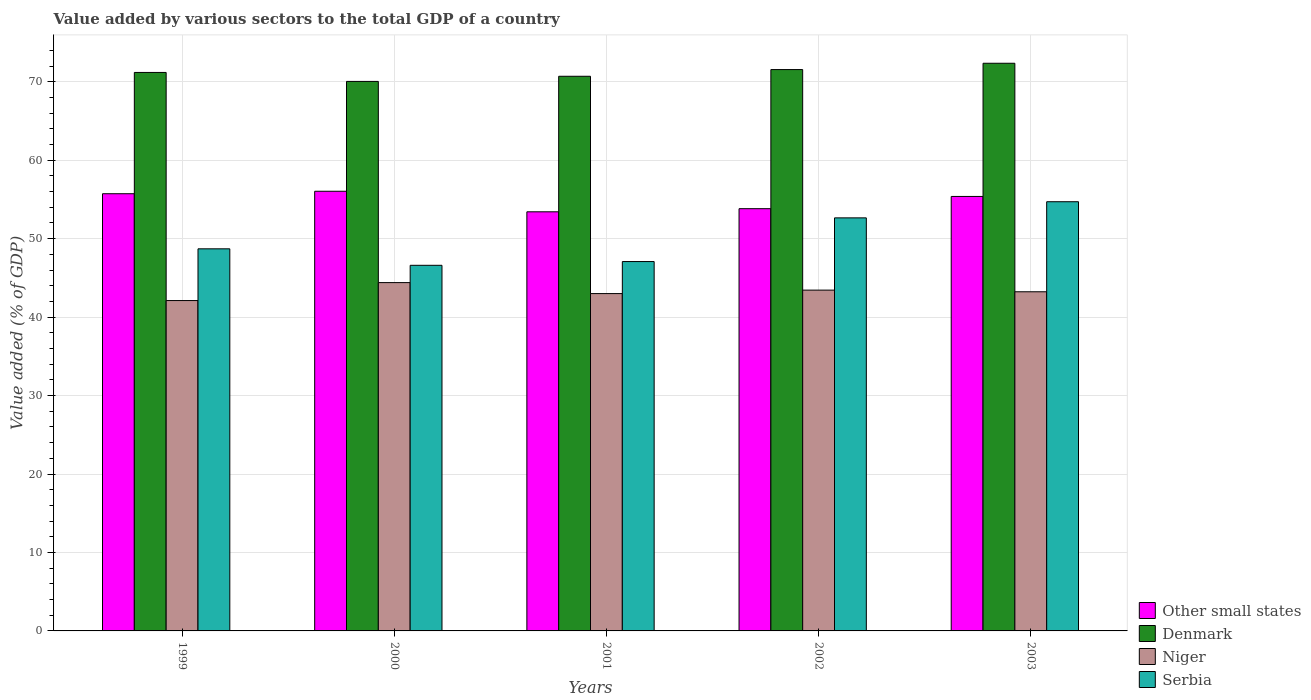How many different coloured bars are there?
Your answer should be very brief. 4. Are the number of bars per tick equal to the number of legend labels?
Ensure brevity in your answer.  Yes. What is the value added by various sectors to the total GDP in Niger in 2000?
Offer a very short reply. 44.4. Across all years, what is the maximum value added by various sectors to the total GDP in Niger?
Your answer should be compact. 44.4. Across all years, what is the minimum value added by various sectors to the total GDP in Other small states?
Keep it short and to the point. 53.43. In which year was the value added by various sectors to the total GDP in Other small states maximum?
Provide a short and direct response. 2000. What is the total value added by various sectors to the total GDP in Other small states in the graph?
Your answer should be compact. 274.41. What is the difference between the value added by various sectors to the total GDP in Denmark in 1999 and that in 2003?
Your answer should be compact. -1.17. What is the difference between the value added by various sectors to the total GDP in Other small states in 2000 and the value added by various sectors to the total GDP in Denmark in 2003?
Your answer should be compact. -16.32. What is the average value added by various sectors to the total GDP in Other small states per year?
Provide a succinct answer. 54.88. In the year 2002, what is the difference between the value added by various sectors to the total GDP in Serbia and value added by various sectors to the total GDP in Denmark?
Offer a very short reply. -18.9. In how many years, is the value added by various sectors to the total GDP in Niger greater than 38 %?
Provide a short and direct response. 5. What is the ratio of the value added by various sectors to the total GDP in Serbia in 2002 to that in 2003?
Your answer should be very brief. 0.96. What is the difference between the highest and the second highest value added by various sectors to the total GDP in Denmark?
Ensure brevity in your answer.  0.8. What is the difference between the highest and the lowest value added by various sectors to the total GDP in Serbia?
Make the answer very short. 8.1. In how many years, is the value added by various sectors to the total GDP in Other small states greater than the average value added by various sectors to the total GDP in Other small states taken over all years?
Give a very brief answer. 3. Is it the case that in every year, the sum of the value added by various sectors to the total GDP in Niger and value added by various sectors to the total GDP in Serbia is greater than the sum of value added by various sectors to the total GDP in Other small states and value added by various sectors to the total GDP in Denmark?
Offer a terse response. No. What does the 3rd bar from the left in 2002 represents?
Keep it short and to the point. Niger. What does the 2nd bar from the right in 2003 represents?
Give a very brief answer. Niger. Is it the case that in every year, the sum of the value added by various sectors to the total GDP in Niger and value added by various sectors to the total GDP in Other small states is greater than the value added by various sectors to the total GDP in Denmark?
Make the answer very short. Yes. What is the difference between two consecutive major ticks on the Y-axis?
Provide a short and direct response. 10. Are the values on the major ticks of Y-axis written in scientific E-notation?
Your answer should be compact. No. Does the graph contain any zero values?
Keep it short and to the point. No. Does the graph contain grids?
Your answer should be compact. Yes. How many legend labels are there?
Offer a terse response. 4. What is the title of the graph?
Provide a succinct answer. Value added by various sectors to the total GDP of a country. What is the label or title of the Y-axis?
Provide a succinct answer. Value added (% of GDP). What is the Value added (% of GDP) in Other small states in 1999?
Give a very brief answer. 55.73. What is the Value added (% of GDP) in Denmark in 1999?
Offer a terse response. 71.19. What is the Value added (% of GDP) in Niger in 1999?
Your response must be concise. 42.11. What is the Value added (% of GDP) in Serbia in 1999?
Give a very brief answer. 48.71. What is the Value added (% of GDP) of Other small states in 2000?
Provide a short and direct response. 56.04. What is the Value added (% of GDP) in Denmark in 2000?
Provide a short and direct response. 70.05. What is the Value added (% of GDP) in Niger in 2000?
Offer a very short reply. 44.4. What is the Value added (% of GDP) of Serbia in 2000?
Ensure brevity in your answer.  46.61. What is the Value added (% of GDP) in Other small states in 2001?
Your answer should be compact. 53.43. What is the Value added (% of GDP) in Denmark in 2001?
Provide a succinct answer. 70.7. What is the Value added (% of GDP) in Niger in 2001?
Your response must be concise. 43. What is the Value added (% of GDP) in Serbia in 2001?
Offer a terse response. 47.08. What is the Value added (% of GDP) in Other small states in 2002?
Offer a terse response. 53.82. What is the Value added (% of GDP) in Denmark in 2002?
Offer a very short reply. 71.56. What is the Value added (% of GDP) of Niger in 2002?
Provide a short and direct response. 43.44. What is the Value added (% of GDP) of Serbia in 2002?
Make the answer very short. 52.65. What is the Value added (% of GDP) of Other small states in 2003?
Offer a terse response. 55.38. What is the Value added (% of GDP) of Denmark in 2003?
Offer a very short reply. 72.36. What is the Value added (% of GDP) in Niger in 2003?
Provide a succinct answer. 43.23. What is the Value added (% of GDP) of Serbia in 2003?
Your answer should be compact. 54.71. Across all years, what is the maximum Value added (% of GDP) in Other small states?
Your response must be concise. 56.04. Across all years, what is the maximum Value added (% of GDP) in Denmark?
Ensure brevity in your answer.  72.36. Across all years, what is the maximum Value added (% of GDP) in Niger?
Offer a terse response. 44.4. Across all years, what is the maximum Value added (% of GDP) of Serbia?
Provide a short and direct response. 54.71. Across all years, what is the minimum Value added (% of GDP) of Other small states?
Make the answer very short. 53.43. Across all years, what is the minimum Value added (% of GDP) of Denmark?
Make the answer very short. 70.05. Across all years, what is the minimum Value added (% of GDP) of Niger?
Your response must be concise. 42.11. Across all years, what is the minimum Value added (% of GDP) of Serbia?
Provide a short and direct response. 46.61. What is the total Value added (% of GDP) of Other small states in the graph?
Give a very brief answer. 274.41. What is the total Value added (% of GDP) in Denmark in the graph?
Provide a short and direct response. 355.86. What is the total Value added (% of GDP) of Niger in the graph?
Your answer should be very brief. 216.19. What is the total Value added (% of GDP) of Serbia in the graph?
Offer a very short reply. 249.76. What is the difference between the Value added (% of GDP) in Other small states in 1999 and that in 2000?
Make the answer very short. -0.31. What is the difference between the Value added (% of GDP) of Denmark in 1999 and that in 2000?
Offer a terse response. 1.14. What is the difference between the Value added (% of GDP) of Niger in 1999 and that in 2000?
Your response must be concise. -2.29. What is the difference between the Value added (% of GDP) in Serbia in 1999 and that in 2000?
Make the answer very short. 2.1. What is the difference between the Value added (% of GDP) of Other small states in 1999 and that in 2001?
Provide a short and direct response. 2.3. What is the difference between the Value added (% of GDP) in Denmark in 1999 and that in 2001?
Provide a succinct answer. 0.49. What is the difference between the Value added (% of GDP) in Niger in 1999 and that in 2001?
Make the answer very short. -0.89. What is the difference between the Value added (% of GDP) of Serbia in 1999 and that in 2001?
Give a very brief answer. 1.62. What is the difference between the Value added (% of GDP) of Other small states in 1999 and that in 2002?
Ensure brevity in your answer.  1.91. What is the difference between the Value added (% of GDP) of Denmark in 1999 and that in 2002?
Your response must be concise. -0.37. What is the difference between the Value added (% of GDP) of Niger in 1999 and that in 2002?
Offer a very short reply. -1.33. What is the difference between the Value added (% of GDP) of Serbia in 1999 and that in 2002?
Provide a short and direct response. -3.95. What is the difference between the Value added (% of GDP) in Other small states in 1999 and that in 2003?
Your answer should be compact. 0.35. What is the difference between the Value added (% of GDP) in Denmark in 1999 and that in 2003?
Keep it short and to the point. -1.17. What is the difference between the Value added (% of GDP) in Niger in 1999 and that in 2003?
Offer a very short reply. -1.12. What is the difference between the Value added (% of GDP) of Serbia in 1999 and that in 2003?
Make the answer very short. -6. What is the difference between the Value added (% of GDP) of Other small states in 2000 and that in 2001?
Make the answer very short. 2.62. What is the difference between the Value added (% of GDP) in Denmark in 2000 and that in 2001?
Make the answer very short. -0.66. What is the difference between the Value added (% of GDP) of Niger in 2000 and that in 2001?
Provide a short and direct response. 1.4. What is the difference between the Value added (% of GDP) in Serbia in 2000 and that in 2001?
Your response must be concise. -0.48. What is the difference between the Value added (% of GDP) in Other small states in 2000 and that in 2002?
Offer a very short reply. 2.22. What is the difference between the Value added (% of GDP) of Denmark in 2000 and that in 2002?
Your response must be concise. -1.51. What is the difference between the Value added (% of GDP) in Niger in 2000 and that in 2002?
Your answer should be very brief. 0.96. What is the difference between the Value added (% of GDP) of Serbia in 2000 and that in 2002?
Give a very brief answer. -6.05. What is the difference between the Value added (% of GDP) of Other small states in 2000 and that in 2003?
Your answer should be very brief. 0.66. What is the difference between the Value added (% of GDP) of Denmark in 2000 and that in 2003?
Keep it short and to the point. -2.31. What is the difference between the Value added (% of GDP) in Niger in 2000 and that in 2003?
Give a very brief answer. 1.17. What is the difference between the Value added (% of GDP) in Serbia in 2000 and that in 2003?
Your answer should be compact. -8.1. What is the difference between the Value added (% of GDP) of Other small states in 2001 and that in 2002?
Give a very brief answer. -0.4. What is the difference between the Value added (% of GDP) of Denmark in 2001 and that in 2002?
Your answer should be very brief. -0.85. What is the difference between the Value added (% of GDP) in Niger in 2001 and that in 2002?
Offer a very short reply. -0.44. What is the difference between the Value added (% of GDP) of Serbia in 2001 and that in 2002?
Keep it short and to the point. -5.57. What is the difference between the Value added (% of GDP) of Other small states in 2001 and that in 2003?
Keep it short and to the point. -1.96. What is the difference between the Value added (% of GDP) in Denmark in 2001 and that in 2003?
Ensure brevity in your answer.  -1.66. What is the difference between the Value added (% of GDP) in Niger in 2001 and that in 2003?
Offer a terse response. -0.23. What is the difference between the Value added (% of GDP) in Serbia in 2001 and that in 2003?
Keep it short and to the point. -7.63. What is the difference between the Value added (% of GDP) of Other small states in 2002 and that in 2003?
Make the answer very short. -1.56. What is the difference between the Value added (% of GDP) in Denmark in 2002 and that in 2003?
Make the answer very short. -0.8. What is the difference between the Value added (% of GDP) in Niger in 2002 and that in 2003?
Offer a very short reply. 0.21. What is the difference between the Value added (% of GDP) of Serbia in 2002 and that in 2003?
Offer a terse response. -2.06. What is the difference between the Value added (% of GDP) of Other small states in 1999 and the Value added (% of GDP) of Denmark in 2000?
Provide a succinct answer. -14.32. What is the difference between the Value added (% of GDP) of Other small states in 1999 and the Value added (% of GDP) of Niger in 2000?
Provide a succinct answer. 11.33. What is the difference between the Value added (% of GDP) in Other small states in 1999 and the Value added (% of GDP) in Serbia in 2000?
Your response must be concise. 9.12. What is the difference between the Value added (% of GDP) of Denmark in 1999 and the Value added (% of GDP) of Niger in 2000?
Your response must be concise. 26.79. What is the difference between the Value added (% of GDP) of Denmark in 1999 and the Value added (% of GDP) of Serbia in 2000?
Your answer should be very brief. 24.58. What is the difference between the Value added (% of GDP) in Niger in 1999 and the Value added (% of GDP) in Serbia in 2000?
Offer a terse response. -4.49. What is the difference between the Value added (% of GDP) in Other small states in 1999 and the Value added (% of GDP) in Denmark in 2001?
Your answer should be compact. -14.97. What is the difference between the Value added (% of GDP) in Other small states in 1999 and the Value added (% of GDP) in Niger in 2001?
Provide a short and direct response. 12.73. What is the difference between the Value added (% of GDP) in Other small states in 1999 and the Value added (% of GDP) in Serbia in 2001?
Make the answer very short. 8.65. What is the difference between the Value added (% of GDP) in Denmark in 1999 and the Value added (% of GDP) in Niger in 2001?
Your answer should be very brief. 28.19. What is the difference between the Value added (% of GDP) in Denmark in 1999 and the Value added (% of GDP) in Serbia in 2001?
Your answer should be compact. 24.11. What is the difference between the Value added (% of GDP) in Niger in 1999 and the Value added (% of GDP) in Serbia in 2001?
Provide a short and direct response. -4.97. What is the difference between the Value added (% of GDP) in Other small states in 1999 and the Value added (% of GDP) in Denmark in 2002?
Your response must be concise. -15.83. What is the difference between the Value added (% of GDP) of Other small states in 1999 and the Value added (% of GDP) of Niger in 2002?
Keep it short and to the point. 12.29. What is the difference between the Value added (% of GDP) of Other small states in 1999 and the Value added (% of GDP) of Serbia in 2002?
Make the answer very short. 3.08. What is the difference between the Value added (% of GDP) in Denmark in 1999 and the Value added (% of GDP) in Niger in 2002?
Your answer should be very brief. 27.75. What is the difference between the Value added (% of GDP) in Denmark in 1999 and the Value added (% of GDP) in Serbia in 2002?
Offer a very short reply. 18.54. What is the difference between the Value added (% of GDP) of Niger in 1999 and the Value added (% of GDP) of Serbia in 2002?
Make the answer very short. -10.54. What is the difference between the Value added (% of GDP) in Other small states in 1999 and the Value added (% of GDP) in Denmark in 2003?
Offer a terse response. -16.63. What is the difference between the Value added (% of GDP) of Other small states in 1999 and the Value added (% of GDP) of Niger in 2003?
Your answer should be very brief. 12.5. What is the difference between the Value added (% of GDP) in Other small states in 1999 and the Value added (% of GDP) in Serbia in 2003?
Your answer should be very brief. 1.02. What is the difference between the Value added (% of GDP) in Denmark in 1999 and the Value added (% of GDP) in Niger in 2003?
Your answer should be very brief. 27.96. What is the difference between the Value added (% of GDP) of Denmark in 1999 and the Value added (% of GDP) of Serbia in 2003?
Provide a succinct answer. 16.48. What is the difference between the Value added (% of GDP) in Niger in 1999 and the Value added (% of GDP) in Serbia in 2003?
Offer a terse response. -12.6. What is the difference between the Value added (% of GDP) of Other small states in 2000 and the Value added (% of GDP) of Denmark in 2001?
Your answer should be very brief. -14.66. What is the difference between the Value added (% of GDP) in Other small states in 2000 and the Value added (% of GDP) in Niger in 2001?
Your answer should be compact. 13.04. What is the difference between the Value added (% of GDP) in Other small states in 2000 and the Value added (% of GDP) in Serbia in 2001?
Provide a succinct answer. 8.96. What is the difference between the Value added (% of GDP) in Denmark in 2000 and the Value added (% of GDP) in Niger in 2001?
Keep it short and to the point. 27.05. What is the difference between the Value added (% of GDP) in Denmark in 2000 and the Value added (% of GDP) in Serbia in 2001?
Your response must be concise. 22.96. What is the difference between the Value added (% of GDP) in Niger in 2000 and the Value added (% of GDP) in Serbia in 2001?
Offer a very short reply. -2.68. What is the difference between the Value added (% of GDP) of Other small states in 2000 and the Value added (% of GDP) of Denmark in 2002?
Keep it short and to the point. -15.51. What is the difference between the Value added (% of GDP) in Other small states in 2000 and the Value added (% of GDP) in Niger in 2002?
Your answer should be very brief. 12.6. What is the difference between the Value added (% of GDP) in Other small states in 2000 and the Value added (% of GDP) in Serbia in 2002?
Your answer should be compact. 3.39. What is the difference between the Value added (% of GDP) of Denmark in 2000 and the Value added (% of GDP) of Niger in 2002?
Make the answer very short. 26.6. What is the difference between the Value added (% of GDP) of Denmark in 2000 and the Value added (% of GDP) of Serbia in 2002?
Your response must be concise. 17.39. What is the difference between the Value added (% of GDP) in Niger in 2000 and the Value added (% of GDP) in Serbia in 2002?
Provide a short and direct response. -8.25. What is the difference between the Value added (% of GDP) in Other small states in 2000 and the Value added (% of GDP) in Denmark in 2003?
Keep it short and to the point. -16.32. What is the difference between the Value added (% of GDP) in Other small states in 2000 and the Value added (% of GDP) in Niger in 2003?
Provide a short and direct response. 12.81. What is the difference between the Value added (% of GDP) in Other small states in 2000 and the Value added (% of GDP) in Serbia in 2003?
Offer a terse response. 1.33. What is the difference between the Value added (% of GDP) in Denmark in 2000 and the Value added (% of GDP) in Niger in 2003?
Offer a terse response. 26.82. What is the difference between the Value added (% of GDP) of Denmark in 2000 and the Value added (% of GDP) of Serbia in 2003?
Keep it short and to the point. 15.34. What is the difference between the Value added (% of GDP) of Niger in 2000 and the Value added (% of GDP) of Serbia in 2003?
Offer a very short reply. -10.31. What is the difference between the Value added (% of GDP) of Other small states in 2001 and the Value added (% of GDP) of Denmark in 2002?
Your answer should be compact. -18.13. What is the difference between the Value added (% of GDP) of Other small states in 2001 and the Value added (% of GDP) of Niger in 2002?
Keep it short and to the point. 9.98. What is the difference between the Value added (% of GDP) in Other small states in 2001 and the Value added (% of GDP) in Serbia in 2002?
Provide a succinct answer. 0.77. What is the difference between the Value added (% of GDP) in Denmark in 2001 and the Value added (% of GDP) in Niger in 2002?
Give a very brief answer. 27.26. What is the difference between the Value added (% of GDP) in Denmark in 2001 and the Value added (% of GDP) in Serbia in 2002?
Make the answer very short. 18.05. What is the difference between the Value added (% of GDP) in Niger in 2001 and the Value added (% of GDP) in Serbia in 2002?
Provide a succinct answer. -9.65. What is the difference between the Value added (% of GDP) in Other small states in 2001 and the Value added (% of GDP) in Denmark in 2003?
Your answer should be very brief. -18.93. What is the difference between the Value added (% of GDP) in Other small states in 2001 and the Value added (% of GDP) in Niger in 2003?
Offer a terse response. 10.19. What is the difference between the Value added (% of GDP) in Other small states in 2001 and the Value added (% of GDP) in Serbia in 2003?
Your answer should be very brief. -1.28. What is the difference between the Value added (% of GDP) in Denmark in 2001 and the Value added (% of GDP) in Niger in 2003?
Your response must be concise. 27.47. What is the difference between the Value added (% of GDP) in Denmark in 2001 and the Value added (% of GDP) in Serbia in 2003?
Make the answer very short. 15.99. What is the difference between the Value added (% of GDP) in Niger in 2001 and the Value added (% of GDP) in Serbia in 2003?
Your answer should be compact. -11.71. What is the difference between the Value added (% of GDP) of Other small states in 2002 and the Value added (% of GDP) of Denmark in 2003?
Your response must be concise. -18.54. What is the difference between the Value added (% of GDP) of Other small states in 2002 and the Value added (% of GDP) of Niger in 2003?
Your answer should be very brief. 10.59. What is the difference between the Value added (% of GDP) in Other small states in 2002 and the Value added (% of GDP) in Serbia in 2003?
Your response must be concise. -0.89. What is the difference between the Value added (% of GDP) of Denmark in 2002 and the Value added (% of GDP) of Niger in 2003?
Offer a very short reply. 28.32. What is the difference between the Value added (% of GDP) of Denmark in 2002 and the Value added (% of GDP) of Serbia in 2003?
Offer a terse response. 16.85. What is the difference between the Value added (% of GDP) in Niger in 2002 and the Value added (% of GDP) in Serbia in 2003?
Offer a very short reply. -11.27. What is the average Value added (% of GDP) of Other small states per year?
Offer a very short reply. 54.88. What is the average Value added (% of GDP) of Denmark per year?
Your answer should be very brief. 71.17. What is the average Value added (% of GDP) in Niger per year?
Offer a terse response. 43.24. What is the average Value added (% of GDP) of Serbia per year?
Offer a very short reply. 49.95. In the year 1999, what is the difference between the Value added (% of GDP) in Other small states and Value added (% of GDP) in Denmark?
Provide a short and direct response. -15.46. In the year 1999, what is the difference between the Value added (% of GDP) of Other small states and Value added (% of GDP) of Niger?
Provide a succinct answer. 13.62. In the year 1999, what is the difference between the Value added (% of GDP) of Other small states and Value added (% of GDP) of Serbia?
Your response must be concise. 7.02. In the year 1999, what is the difference between the Value added (% of GDP) of Denmark and Value added (% of GDP) of Niger?
Provide a short and direct response. 29.08. In the year 1999, what is the difference between the Value added (% of GDP) of Denmark and Value added (% of GDP) of Serbia?
Your answer should be very brief. 22.48. In the year 1999, what is the difference between the Value added (% of GDP) in Niger and Value added (% of GDP) in Serbia?
Give a very brief answer. -6.59. In the year 2000, what is the difference between the Value added (% of GDP) of Other small states and Value added (% of GDP) of Denmark?
Provide a short and direct response. -14. In the year 2000, what is the difference between the Value added (% of GDP) in Other small states and Value added (% of GDP) in Niger?
Your answer should be very brief. 11.64. In the year 2000, what is the difference between the Value added (% of GDP) in Other small states and Value added (% of GDP) in Serbia?
Ensure brevity in your answer.  9.44. In the year 2000, what is the difference between the Value added (% of GDP) in Denmark and Value added (% of GDP) in Niger?
Provide a succinct answer. 25.65. In the year 2000, what is the difference between the Value added (% of GDP) of Denmark and Value added (% of GDP) of Serbia?
Your response must be concise. 23.44. In the year 2000, what is the difference between the Value added (% of GDP) in Niger and Value added (% of GDP) in Serbia?
Provide a short and direct response. -2.21. In the year 2001, what is the difference between the Value added (% of GDP) of Other small states and Value added (% of GDP) of Denmark?
Your answer should be compact. -17.28. In the year 2001, what is the difference between the Value added (% of GDP) of Other small states and Value added (% of GDP) of Niger?
Make the answer very short. 10.42. In the year 2001, what is the difference between the Value added (% of GDP) of Other small states and Value added (% of GDP) of Serbia?
Ensure brevity in your answer.  6.34. In the year 2001, what is the difference between the Value added (% of GDP) of Denmark and Value added (% of GDP) of Niger?
Keep it short and to the point. 27.7. In the year 2001, what is the difference between the Value added (% of GDP) of Denmark and Value added (% of GDP) of Serbia?
Your answer should be very brief. 23.62. In the year 2001, what is the difference between the Value added (% of GDP) in Niger and Value added (% of GDP) in Serbia?
Keep it short and to the point. -4.08. In the year 2002, what is the difference between the Value added (% of GDP) in Other small states and Value added (% of GDP) in Denmark?
Offer a terse response. -17.73. In the year 2002, what is the difference between the Value added (% of GDP) of Other small states and Value added (% of GDP) of Niger?
Offer a very short reply. 10.38. In the year 2002, what is the difference between the Value added (% of GDP) of Other small states and Value added (% of GDP) of Serbia?
Your answer should be very brief. 1.17. In the year 2002, what is the difference between the Value added (% of GDP) in Denmark and Value added (% of GDP) in Niger?
Ensure brevity in your answer.  28.11. In the year 2002, what is the difference between the Value added (% of GDP) in Denmark and Value added (% of GDP) in Serbia?
Give a very brief answer. 18.9. In the year 2002, what is the difference between the Value added (% of GDP) in Niger and Value added (% of GDP) in Serbia?
Give a very brief answer. -9.21. In the year 2003, what is the difference between the Value added (% of GDP) in Other small states and Value added (% of GDP) in Denmark?
Provide a succinct answer. -16.98. In the year 2003, what is the difference between the Value added (% of GDP) in Other small states and Value added (% of GDP) in Niger?
Your response must be concise. 12.15. In the year 2003, what is the difference between the Value added (% of GDP) of Other small states and Value added (% of GDP) of Serbia?
Provide a succinct answer. 0.67. In the year 2003, what is the difference between the Value added (% of GDP) in Denmark and Value added (% of GDP) in Niger?
Your response must be concise. 29.13. In the year 2003, what is the difference between the Value added (% of GDP) of Denmark and Value added (% of GDP) of Serbia?
Offer a very short reply. 17.65. In the year 2003, what is the difference between the Value added (% of GDP) in Niger and Value added (% of GDP) in Serbia?
Your response must be concise. -11.48. What is the ratio of the Value added (% of GDP) of Other small states in 1999 to that in 2000?
Make the answer very short. 0.99. What is the ratio of the Value added (% of GDP) in Denmark in 1999 to that in 2000?
Provide a short and direct response. 1.02. What is the ratio of the Value added (% of GDP) in Niger in 1999 to that in 2000?
Give a very brief answer. 0.95. What is the ratio of the Value added (% of GDP) of Serbia in 1999 to that in 2000?
Give a very brief answer. 1.05. What is the ratio of the Value added (% of GDP) in Other small states in 1999 to that in 2001?
Offer a very short reply. 1.04. What is the ratio of the Value added (% of GDP) of Denmark in 1999 to that in 2001?
Offer a very short reply. 1.01. What is the ratio of the Value added (% of GDP) in Niger in 1999 to that in 2001?
Offer a terse response. 0.98. What is the ratio of the Value added (% of GDP) in Serbia in 1999 to that in 2001?
Your answer should be compact. 1.03. What is the ratio of the Value added (% of GDP) of Other small states in 1999 to that in 2002?
Make the answer very short. 1.04. What is the ratio of the Value added (% of GDP) of Denmark in 1999 to that in 2002?
Make the answer very short. 0.99. What is the ratio of the Value added (% of GDP) of Niger in 1999 to that in 2002?
Give a very brief answer. 0.97. What is the ratio of the Value added (% of GDP) of Serbia in 1999 to that in 2002?
Your response must be concise. 0.93. What is the ratio of the Value added (% of GDP) in Other small states in 1999 to that in 2003?
Your answer should be very brief. 1.01. What is the ratio of the Value added (% of GDP) of Denmark in 1999 to that in 2003?
Your response must be concise. 0.98. What is the ratio of the Value added (% of GDP) of Niger in 1999 to that in 2003?
Your answer should be compact. 0.97. What is the ratio of the Value added (% of GDP) of Serbia in 1999 to that in 2003?
Your answer should be very brief. 0.89. What is the ratio of the Value added (% of GDP) of Other small states in 2000 to that in 2001?
Provide a succinct answer. 1.05. What is the ratio of the Value added (% of GDP) of Niger in 2000 to that in 2001?
Ensure brevity in your answer.  1.03. What is the ratio of the Value added (% of GDP) in Other small states in 2000 to that in 2002?
Offer a terse response. 1.04. What is the ratio of the Value added (% of GDP) of Denmark in 2000 to that in 2002?
Your answer should be compact. 0.98. What is the ratio of the Value added (% of GDP) in Serbia in 2000 to that in 2002?
Provide a succinct answer. 0.89. What is the ratio of the Value added (% of GDP) in Other small states in 2000 to that in 2003?
Ensure brevity in your answer.  1.01. What is the ratio of the Value added (% of GDP) of Denmark in 2000 to that in 2003?
Keep it short and to the point. 0.97. What is the ratio of the Value added (% of GDP) in Niger in 2000 to that in 2003?
Your answer should be very brief. 1.03. What is the ratio of the Value added (% of GDP) of Serbia in 2000 to that in 2003?
Keep it short and to the point. 0.85. What is the ratio of the Value added (% of GDP) of Other small states in 2001 to that in 2002?
Your answer should be very brief. 0.99. What is the ratio of the Value added (% of GDP) of Niger in 2001 to that in 2002?
Provide a short and direct response. 0.99. What is the ratio of the Value added (% of GDP) in Serbia in 2001 to that in 2002?
Provide a short and direct response. 0.89. What is the ratio of the Value added (% of GDP) in Other small states in 2001 to that in 2003?
Your answer should be compact. 0.96. What is the ratio of the Value added (% of GDP) of Denmark in 2001 to that in 2003?
Provide a succinct answer. 0.98. What is the ratio of the Value added (% of GDP) in Niger in 2001 to that in 2003?
Offer a very short reply. 0.99. What is the ratio of the Value added (% of GDP) in Serbia in 2001 to that in 2003?
Your answer should be very brief. 0.86. What is the ratio of the Value added (% of GDP) in Other small states in 2002 to that in 2003?
Offer a very short reply. 0.97. What is the ratio of the Value added (% of GDP) in Denmark in 2002 to that in 2003?
Offer a terse response. 0.99. What is the ratio of the Value added (% of GDP) of Niger in 2002 to that in 2003?
Make the answer very short. 1. What is the ratio of the Value added (% of GDP) of Serbia in 2002 to that in 2003?
Offer a very short reply. 0.96. What is the difference between the highest and the second highest Value added (% of GDP) of Other small states?
Your response must be concise. 0.31. What is the difference between the highest and the second highest Value added (% of GDP) in Denmark?
Provide a succinct answer. 0.8. What is the difference between the highest and the second highest Value added (% of GDP) in Niger?
Offer a very short reply. 0.96. What is the difference between the highest and the second highest Value added (% of GDP) of Serbia?
Keep it short and to the point. 2.06. What is the difference between the highest and the lowest Value added (% of GDP) of Other small states?
Your answer should be compact. 2.62. What is the difference between the highest and the lowest Value added (% of GDP) of Denmark?
Your answer should be very brief. 2.31. What is the difference between the highest and the lowest Value added (% of GDP) of Niger?
Keep it short and to the point. 2.29. What is the difference between the highest and the lowest Value added (% of GDP) of Serbia?
Offer a very short reply. 8.1. 